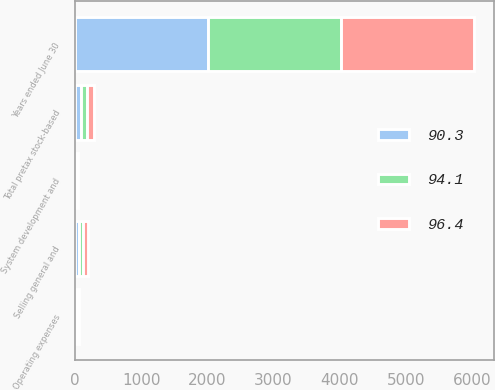Convert chart. <chart><loc_0><loc_0><loc_500><loc_500><stacked_bar_chart><ecel><fcel>Years ended June 30<fcel>Operating expenses<fcel>Selling general and<fcel>System development and<fcel>Total pretax stock-based<nl><fcel>96.4<fcel>2013<fcel>17.9<fcel>64<fcel>14.5<fcel>96.4<nl><fcel>90.3<fcel>2012<fcel>17.2<fcel>62.6<fcel>14.3<fcel>94.1<nl><fcel>94.1<fcel>2011<fcel>16.5<fcel>59.9<fcel>13.9<fcel>90.3<nl></chart> 